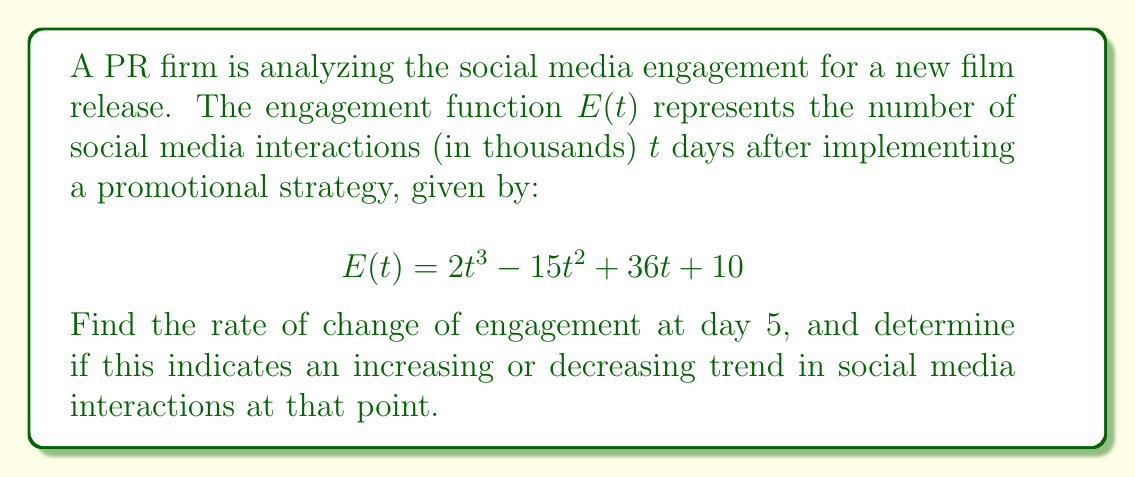Could you help me with this problem? To solve this problem, we need to follow these steps:

1) The rate of change of engagement is represented by the derivative of the engagement function $E(t)$. Let's call this $E'(t)$.

2) To find $E'(t)$, we differentiate $E(t)$ with respect to $t$:

   $$E'(t) = \frac{d}{dt}(2t^3 - 15t^2 + 36t + 10)$$
   $$E'(t) = 6t^2 - 30t + 36$$

3) Now that we have $E'(t)$, we can find the rate of change at day 5 by evaluating $E'(5)$:

   $$E'(5) = 6(5)^2 - 30(5) + 36$$
   $$E'(5) = 6(25) - 150 + 36$$
   $$E'(5) = 150 - 150 + 36 = 36$$

4) The rate of change at day 5 is 36 thousand interactions per day.

5) To determine if this indicates an increasing or decreasing trend, we look at the sign of $E'(5)$:
   - If $E'(5) > 0$, the trend is increasing
   - If $E'(5) < 0$, the trend is decreasing
   - If $E'(5) = 0$, there is no change (stationary point)

   Since $E'(5) = 36 > 0$, the trend is increasing at day 5.
Answer: 36 thousand interactions/day, increasing trend 